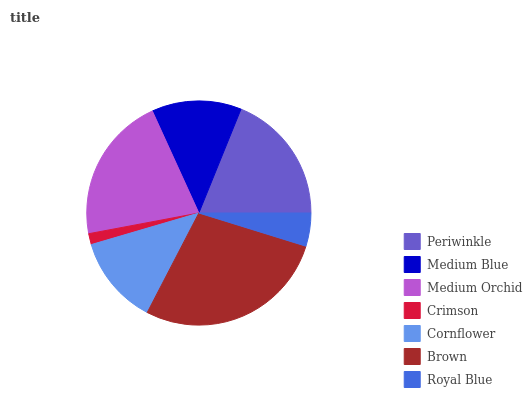Is Crimson the minimum?
Answer yes or no. Yes. Is Brown the maximum?
Answer yes or no. Yes. Is Medium Blue the minimum?
Answer yes or no. No. Is Medium Blue the maximum?
Answer yes or no. No. Is Periwinkle greater than Medium Blue?
Answer yes or no. Yes. Is Medium Blue less than Periwinkle?
Answer yes or no. Yes. Is Medium Blue greater than Periwinkle?
Answer yes or no. No. Is Periwinkle less than Medium Blue?
Answer yes or no. No. Is Medium Blue the high median?
Answer yes or no. Yes. Is Medium Blue the low median?
Answer yes or no. Yes. Is Medium Orchid the high median?
Answer yes or no. No. Is Medium Orchid the low median?
Answer yes or no. No. 